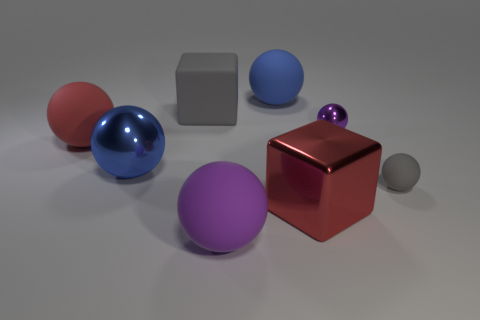Are there any blue spheres of the same size as the purple metal ball?
Your answer should be very brief. No. How big is the matte object to the right of the blue ball to the right of the large purple matte sphere?
Offer a terse response. Small. Are there fewer big matte blocks in front of the red block than red cubes?
Provide a short and direct response. Yes. Is the matte cube the same color as the tiny matte thing?
Make the answer very short. Yes. What is the size of the gray sphere?
Give a very brief answer. Small. How many balls are the same color as the metallic block?
Ensure brevity in your answer.  1. Is there a large rubber ball that is in front of the big matte object that is on the left side of the large blue object that is in front of the purple shiny object?
Give a very brief answer. Yes. What is the shape of the gray thing that is the same size as the red rubber sphere?
Keep it short and to the point. Cube. How many tiny things are shiny balls or cyan matte blocks?
Offer a very short reply. 1. The cube that is made of the same material as the small purple object is what color?
Provide a succinct answer. Red. 